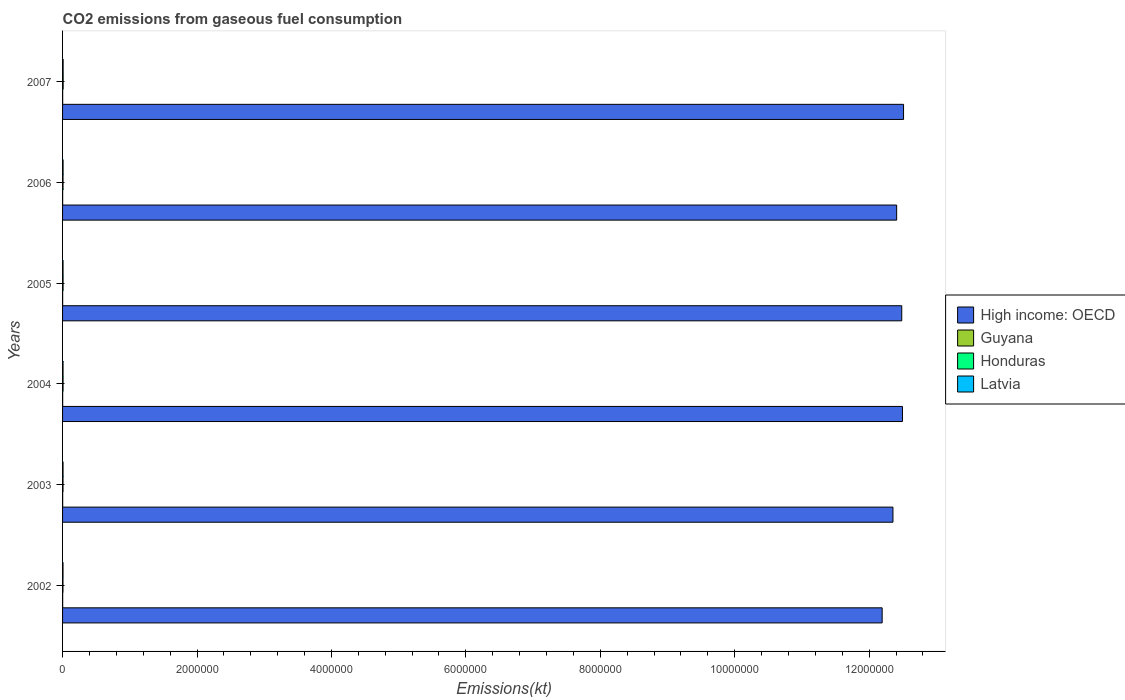Are the number of bars per tick equal to the number of legend labels?
Keep it short and to the point. Yes. Are the number of bars on each tick of the Y-axis equal?
Your response must be concise. Yes. How many bars are there on the 2nd tick from the bottom?
Your answer should be compact. 4. What is the label of the 5th group of bars from the top?
Offer a very short reply. 2003. What is the amount of CO2 emitted in High income: OECD in 2007?
Offer a very short reply. 1.25e+07. Across all years, what is the maximum amount of CO2 emitted in Honduras?
Give a very brief answer. 8778.8. Across all years, what is the minimum amount of CO2 emitted in High income: OECD?
Offer a very short reply. 1.22e+07. In which year was the amount of CO2 emitted in Latvia maximum?
Offer a very short reply. 2007. What is the total amount of CO2 emitted in High income: OECD in the graph?
Offer a terse response. 7.44e+07. What is the difference between the amount of CO2 emitted in Latvia in 2005 and that in 2007?
Your answer should be very brief. -1140.44. What is the difference between the amount of CO2 emitted in Latvia in 2006 and the amount of CO2 emitted in High income: OECD in 2005?
Provide a short and direct response. -1.25e+07. What is the average amount of CO2 emitted in Honduras per year?
Offer a terse response. 7261.27. In the year 2006, what is the difference between the amount of CO2 emitted in High income: OECD and amount of CO2 emitted in Guyana?
Your answer should be compact. 1.24e+07. What is the ratio of the amount of CO2 emitted in Latvia in 2003 to that in 2007?
Ensure brevity in your answer.  0.85. What is the difference between the highest and the second highest amount of CO2 emitted in Guyana?
Keep it short and to the point. 47.67. What is the difference between the highest and the lowest amount of CO2 emitted in Honduras?
Ensure brevity in your answer.  2687.91. Is the sum of the amount of CO2 emitted in Guyana in 2002 and 2003 greater than the maximum amount of CO2 emitted in Latvia across all years?
Keep it short and to the point. No. Is it the case that in every year, the sum of the amount of CO2 emitted in Guyana and amount of CO2 emitted in High income: OECD is greater than the sum of amount of CO2 emitted in Latvia and amount of CO2 emitted in Honduras?
Ensure brevity in your answer.  Yes. What does the 2nd bar from the top in 2004 represents?
Provide a succinct answer. Honduras. What does the 4th bar from the bottom in 2003 represents?
Give a very brief answer. Latvia. Is it the case that in every year, the sum of the amount of CO2 emitted in Guyana and amount of CO2 emitted in Honduras is greater than the amount of CO2 emitted in High income: OECD?
Your answer should be very brief. No. How many bars are there?
Provide a succinct answer. 24. How many years are there in the graph?
Offer a very short reply. 6. Does the graph contain grids?
Your answer should be compact. No. How many legend labels are there?
Offer a very short reply. 4. What is the title of the graph?
Keep it short and to the point. CO2 emissions from gaseous fuel consumption. Does "Libya" appear as one of the legend labels in the graph?
Make the answer very short. No. What is the label or title of the X-axis?
Your answer should be compact. Emissions(kt). What is the label or title of the Y-axis?
Give a very brief answer. Years. What is the Emissions(kt) of High income: OECD in 2002?
Offer a terse response. 1.22e+07. What is the Emissions(kt) of Guyana in 2002?
Provide a succinct answer. 1580.48. What is the Emissions(kt) of Honduras in 2002?
Give a very brief answer. 6090.89. What is the Emissions(kt) of Latvia in 2002?
Ensure brevity in your answer.  6651.94. What is the Emissions(kt) in High income: OECD in 2003?
Provide a short and direct response. 1.24e+07. What is the Emissions(kt) in Guyana in 2003?
Your response must be concise. 1565.81. What is the Emissions(kt) of Honduras in 2003?
Offer a very short reply. 6769.28. What is the Emissions(kt) of Latvia in 2003?
Ensure brevity in your answer.  7088.31. What is the Emissions(kt) in High income: OECD in 2004?
Offer a terse response. 1.25e+07. What is the Emissions(kt) of Guyana in 2004?
Your response must be concise. 1628.15. What is the Emissions(kt) of Honduras in 2004?
Your answer should be compact. 7367. What is the Emissions(kt) in Latvia in 2004?
Offer a very short reply. 7132.31. What is the Emissions(kt) in High income: OECD in 2005?
Provide a succinct answer. 1.25e+07. What is the Emissions(kt) in Guyana in 2005?
Offer a terse response. 1437.46. What is the Emissions(kt) in Honduras in 2005?
Give a very brief answer. 7554.02. What is the Emissions(kt) of Latvia in 2005?
Keep it short and to the point. 7176.32. What is the Emissions(kt) in High income: OECD in 2006?
Provide a succinct answer. 1.24e+07. What is the Emissions(kt) in Guyana in 2006?
Make the answer very short. 1290.78. What is the Emissions(kt) of Honduras in 2006?
Offer a very short reply. 7007.64. What is the Emissions(kt) of Latvia in 2006?
Provide a succinct answer. 7583.36. What is the Emissions(kt) of High income: OECD in 2007?
Provide a succinct answer. 1.25e+07. What is the Emissions(kt) in Guyana in 2007?
Ensure brevity in your answer.  1562.14. What is the Emissions(kt) in Honduras in 2007?
Offer a terse response. 8778.8. What is the Emissions(kt) of Latvia in 2007?
Give a very brief answer. 8316.76. Across all years, what is the maximum Emissions(kt) in High income: OECD?
Provide a succinct answer. 1.25e+07. Across all years, what is the maximum Emissions(kt) of Guyana?
Offer a very short reply. 1628.15. Across all years, what is the maximum Emissions(kt) of Honduras?
Keep it short and to the point. 8778.8. Across all years, what is the maximum Emissions(kt) in Latvia?
Ensure brevity in your answer.  8316.76. Across all years, what is the minimum Emissions(kt) in High income: OECD?
Your response must be concise. 1.22e+07. Across all years, what is the minimum Emissions(kt) of Guyana?
Ensure brevity in your answer.  1290.78. Across all years, what is the minimum Emissions(kt) of Honduras?
Your answer should be very brief. 6090.89. Across all years, what is the minimum Emissions(kt) in Latvia?
Keep it short and to the point. 6651.94. What is the total Emissions(kt) in High income: OECD in the graph?
Offer a very short reply. 7.44e+07. What is the total Emissions(kt) of Guyana in the graph?
Provide a succinct answer. 9064.82. What is the total Emissions(kt) of Honduras in the graph?
Offer a very short reply. 4.36e+04. What is the total Emissions(kt) in Latvia in the graph?
Give a very brief answer. 4.39e+04. What is the difference between the Emissions(kt) of High income: OECD in 2002 and that in 2003?
Your answer should be compact. -1.61e+05. What is the difference between the Emissions(kt) in Guyana in 2002 and that in 2003?
Provide a short and direct response. 14.67. What is the difference between the Emissions(kt) of Honduras in 2002 and that in 2003?
Offer a terse response. -678.39. What is the difference between the Emissions(kt) of Latvia in 2002 and that in 2003?
Offer a terse response. -436.37. What is the difference between the Emissions(kt) of High income: OECD in 2002 and that in 2004?
Keep it short and to the point. -3.02e+05. What is the difference between the Emissions(kt) in Guyana in 2002 and that in 2004?
Your response must be concise. -47.67. What is the difference between the Emissions(kt) in Honduras in 2002 and that in 2004?
Ensure brevity in your answer.  -1276.12. What is the difference between the Emissions(kt) of Latvia in 2002 and that in 2004?
Offer a terse response. -480.38. What is the difference between the Emissions(kt) of High income: OECD in 2002 and that in 2005?
Your answer should be compact. -2.91e+05. What is the difference between the Emissions(kt) of Guyana in 2002 and that in 2005?
Provide a short and direct response. 143.01. What is the difference between the Emissions(kt) of Honduras in 2002 and that in 2005?
Make the answer very short. -1463.13. What is the difference between the Emissions(kt) in Latvia in 2002 and that in 2005?
Your answer should be compact. -524.38. What is the difference between the Emissions(kt) of High income: OECD in 2002 and that in 2006?
Provide a short and direct response. -2.16e+05. What is the difference between the Emissions(kt) of Guyana in 2002 and that in 2006?
Provide a succinct answer. 289.69. What is the difference between the Emissions(kt) of Honduras in 2002 and that in 2006?
Offer a very short reply. -916.75. What is the difference between the Emissions(kt) of Latvia in 2002 and that in 2006?
Offer a very short reply. -931.42. What is the difference between the Emissions(kt) in High income: OECD in 2002 and that in 2007?
Provide a short and direct response. -3.18e+05. What is the difference between the Emissions(kt) of Guyana in 2002 and that in 2007?
Ensure brevity in your answer.  18.34. What is the difference between the Emissions(kt) of Honduras in 2002 and that in 2007?
Make the answer very short. -2687.91. What is the difference between the Emissions(kt) of Latvia in 2002 and that in 2007?
Offer a very short reply. -1664.82. What is the difference between the Emissions(kt) in High income: OECD in 2003 and that in 2004?
Keep it short and to the point. -1.41e+05. What is the difference between the Emissions(kt) in Guyana in 2003 and that in 2004?
Keep it short and to the point. -62.34. What is the difference between the Emissions(kt) in Honduras in 2003 and that in 2004?
Keep it short and to the point. -597.72. What is the difference between the Emissions(kt) of Latvia in 2003 and that in 2004?
Offer a very short reply. -44. What is the difference between the Emissions(kt) in High income: OECD in 2003 and that in 2005?
Make the answer very short. -1.31e+05. What is the difference between the Emissions(kt) in Guyana in 2003 and that in 2005?
Provide a short and direct response. 128.34. What is the difference between the Emissions(kt) in Honduras in 2003 and that in 2005?
Make the answer very short. -784.74. What is the difference between the Emissions(kt) of Latvia in 2003 and that in 2005?
Ensure brevity in your answer.  -88.01. What is the difference between the Emissions(kt) in High income: OECD in 2003 and that in 2006?
Ensure brevity in your answer.  -5.51e+04. What is the difference between the Emissions(kt) in Guyana in 2003 and that in 2006?
Offer a terse response. 275.02. What is the difference between the Emissions(kt) of Honduras in 2003 and that in 2006?
Provide a short and direct response. -238.35. What is the difference between the Emissions(kt) in Latvia in 2003 and that in 2006?
Your response must be concise. -495.05. What is the difference between the Emissions(kt) in High income: OECD in 2003 and that in 2007?
Keep it short and to the point. -1.58e+05. What is the difference between the Emissions(kt) of Guyana in 2003 and that in 2007?
Offer a terse response. 3.67. What is the difference between the Emissions(kt) of Honduras in 2003 and that in 2007?
Keep it short and to the point. -2009.52. What is the difference between the Emissions(kt) of Latvia in 2003 and that in 2007?
Offer a very short reply. -1228.44. What is the difference between the Emissions(kt) of High income: OECD in 2004 and that in 2005?
Keep it short and to the point. 1.07e+04. What is the difference between the Emissions(kt) of Guyana in 2004 and that in 2005?
Your answer should be compact. 190.68. What is the difference between the Emissions(kt) in Honduras in 2004 and that in 2005?
Your answer should be compact. -187.02. What is the difference between the Emissions(kt) in Latvia in 2004 and that in 2005?
Your answer should be compact. -44. What is the difference between the Emissions(kt) of High income: OECD in 2004 and that in 2006?
Give a very brief answer. 8.64e+04. What is the difference between the Emissions(kt) in Guyana in 2004 and that in 2006?
Provide a short and direct response. 337.36. What is the difference between the Emissions(kt) of Honduras in 2004 and that in 2006?
Offer a terse response. 359.37. What is the difference between the Emissions(kt) in Latvia in 2004 and that in 2006?
Offer a terse response. -451.04. What is the difference between the Emissions(kt) in High income: OECD in 2004 and that in 2007?
Your answer should be very brief. -1.61e+04. What is the difference between the Emissions(kt) in Guyana in 2004 and that in 2007?
Provide a short and direct response. 66.01. What is the difference between the Emissions(kt) of Honduras in 2004 and that in 2007?
Keep it short and to the point. -1411.8. What is the difference between the Emissions(kt) of Latvia in 2004 and that in 2007?
Offer a terse response. -1184.44. What is the difference between the Emissions(kt) of High income: OECD in 2005 and that in 2006?
Ensure brevity in your answer.  7.57e+04. What is the difference between the Emissions(kt) of Guyana in 2005 and that in 2006?
Offer a very short reply. 146.68. What is the difference between the Emissions(kt) of Honduras in 2005 and that in 2006?
Ensure brevity in your answer.  546.38. What is the difference between the Emissions(kt) of Latvia in 2005 and that in 2006?
Your answer should be compact. -407.04. What is the difference between the Emissions(kt) in High income: OECD in 2005 and that in 2007?
Ensure brevity in your answer.  -2.69e+04. What is the difference between the Emissions(kt) of Guyana in 2005 and that in 2007?
Offer a terse response. -124.68. What is the difference between the Emissions(kt) in Honduras in 2005 and that in 2007?
Your response must be concise. -1224.78. What is the difference between the Emissions(kt) in Latvia in 2005 and that in 2007?
Your answer should be very brief. -1140.44. What is the difference between the Emissions(kt) of High income: OECD in 2006 and that in 2007?
Provide a succinct answer. -1.03e+05. What is the difference between the Emissions(kt) of Guyana in 2006 and that in 2007?
Your answer should be very brief. -271.36. What is the difference between the Emissions(kt) in Honduras in 2006 and that in 2007?
Make the answer very short. -1771.16. What is the difference between the Emissions(kt) of Latvia in 2006 and that in 2007?
Ensure brevity in your answer.  -733.4. What is the difference between the Emissions(kt) in High income: OECD in 2002 and the Emissions(kt) in Guyana in 2003?
Your response must be concise. 1.22e+07. What is the difference between the Emissions(kt) of High income: OECD in 2002 and the Emissions(kt) of Honduras in 2003?
Ensure brevity in your answer.  1.22e+07. What is the difference between the Emissions(kt) of High income: OECD in 2002 and the Emissions(kt) of Latvia in 2003?
Provide a succinct answer. 1.22e+07. What is the difference between the Emissions(kt) of Guyana in 2002 and the Emissions(kt) of Honduras in 2003?
Your answer should be compact. -5188.81. What is the difference between the Emissions(kt) in Guyana in 2002 and the Emissions(kt) in Latvia in 2003?
Offer a terse response. -5507.83. What is the difference between the Emissions(kt) of Honduras in 2002 and the Emissions(kt) of Latvia in 2003?
Provide a short and direct response. -997.42. What is the difference between the Emissions(kt) of High income: OECD in 2002 and the Emissions(kt) of Guyana in 2004?
Your answer should be compact. 1.22e+07. What is the difference between the Emissions(kt) of High income: OECD in 2002 and the Emissions(kt) of Honduras in 2004?
Provide a short and direct response. 1.22e+07. What is the difference between the Emissions(kt) of High income: OECD in 2002 and the Emissions(kt) of Latvia in 2004?
Make the answer very short. 1.22e+07. What is the difference between the Emissions(kt) of Guyana in 2002 and the Emissions(kt) of Honduras in 2004?
Your answer should be compact. -5786.53. What is the difference between the Emissions(kt) of Guyana in 2002 and the Emissions(kt) of Latvia in 2004?
Your answer should be very brief. -5551.84. What is the difference between the Emissions(kt) of Honduras in 2002 and the Emissions(kt) of Latvia in 2004?
Give a very brief answer. -1041.43. What is the difference between the Emissions(kt) in High income: OECD in 2002 and the Emissions(kt) in Guyana in 2005?
Provide a short and direct response. 1.22e+07. What is the difference between the Emissions(kt) in High income: OECD in 2002 and the Emissions(kt) in Honduras in 2005?
Provide a short and direct response. 1.22e+07. What is the difference between the Emissions(kt) in High income: OECD in 2002 and the Emissions(kt) in Latvia in 2005?
Give a very brief answer. 1.22e+07. What is the difference between the Emissions(kt) of Guyana in 2002 and the Emissions(kt) of Honduras in 2005?
Your response must be concise. -5973.54. What is the difference between the Emissions(kt) of Guyana in 2002 and the Emissions(kt) of Latvia in 2005?
Your answer should be very brief. -5595.84. What is the difference between the Emissions(kt) of Honduras in 2002 and the Emissions(kt) of Latvia in 2005?
Your answer should be very brief. -1085.43. What is the difference between the Emissions(kt) of High income: OECD in 2002 and the Emissions(kt) of Guyana in 2006?
Your response must be concise. 1.22e+07. What is the difference between the Emissions(kt) of High income: OECD in 2002 and the Emissions(kt) of Honduras in 2006?
Ensure brevity in your answer.  1.22e+07. What is the difference between the Emissions(kt) in High income: OECD in 2002 and the Emissions(kt) in Latvia in 2006?
Your answer should be compact. 1.22e+07. What is the difference between the Emissions(kt) of Guyana in 2002 and the Emissions(kt) of Honduras in 2006?
Ensure brevity in your answer.  -5427.16. What is the difference between the Emissions(kt) of Guyana in 2002 and the Emissions(kt) of Latvia in 2006?
Give a very brief answer. -6002.88. What is the difference between the Emissions(kt) of Honduras in 2002 and the Emissions(kt) of Latvia in 2006?
Make the answer very short. -1492.47. What is the difference between the Emissions(kt) in High income: OECD in 2002 and the Emissions(kt) in Guyana in 2007?
Provide a short and direct response. 1.22e+07. What is the difference between the Emissions(kt) in High income: OECD in 2002 and the Emissions(kt) in Honduras in 2007?
Your response must be concise. 1.22e+07. What is the difference between the Emissions(kt) of High income: OECD in 2002 and the Emissions(kt) of Latvia in 2007?
Provide a succinct answer. 1.22e+07. What is the difference between the Emissions(kt) in Guyana in 2002 and the Emissions(kt) in Honduras in 2007?
Give a very brief answer. -7198.32. What is the difference between the Emissions(kt) in Guyana in 2002 and the Emissions(kt) in Latvia in 2007?
Ensure brevity in your answer.  -6736.28. What is the difference between the Emissions(kt) in Honduras in 2002 and the Emissions(kt) in Latvia in 2007?
Provide a short and direct response. -2225.87. What is the difference between the Emissions(kt) of High income: OECD in 2003 and the Emissions(kt) of Guyana in 2004?
Give a very brief answer. 1.24e+07. What is the difference between the Emissions(kt) of High income: OECD in 2003 and the Emissions(kt) of Honduras in 2004?
Your response must be concise. 1.23e+07. What is the difference between the Emissions(kt) in High income: OECD in 2003 and the Emissions(kt) in Latvia in 2004?
Keep it short and to the point. 1.23e+07. What is the difference between the Emissions(kt) in Guyana in 2003 and the Emissions(kt) in Honduras in 2004?
Provide a succinct answer. -5801.19. What is the difference between the Emissions(kt) of Guyana in 2003 and the Emissions(kt) of Latvia in 2004?
Provide a succinct answer. -5566.51. What is the difference between the Emissions(kt) in Honduras in 2003 and the Emissions(kt) in Latvia in 2004?
Provide a succinct answer. -363.03. What is the difference between the Emissions(kt) in High income: OECD in 2003 and the Emissions(kt) in Guyana in 2005?
Offer a very short reply. 1.24e+07. What is the difference between the Emissions(kt) in High income: OECD in 2003 and the Emissions(kt) in Honduras in 2005?
Your answer should be compact. 1.23e+07. What is the difference between the Emissions(kt) of High income: OECD in 2003 and the Emissions(kt) of Latvia in 2005?
Offer a very short reply. 1.23e+07. What is the difference between the Emissions(kt) in Guyana in 2003 and the Emissions(kt) in Honduras in 2005?
Provide a short and direct response. -5988.21. What is the difference between the Emissions(kt) in Guyana in 2003 and the Emissions(kt) in Latvia in 2005?
Keep it short and to the point. -5610.51. What is the difference between the Emissions(kt) in Honduras in 2003 and the Emissions(kt) in Latvia in 2005?
Ensure brevity in your answer.  -407.04. What is the difference between the Emissions(kt) in High income: OECD in 2003 and the Emissions(kt) in Guyana in 2006?
Give a very brief answer. 1.24e+07. What is the difference between the Emissions(kt) of High income: OECD in 2003 and the Emissions(kt) of Honduras in 2006?
Provide a succinct answer. 1.23e+07. What is the difference between the Emissions(kt) of High income: OECD in 2003 and the Emissions(kt) of Latvia in 2006?
Offer a terse response. 1.23e+07. What is the difference between the Emissions(kt) of Guyana in 2003 and the Emissions(kt) of Honduras in 2006?
Your answer should be compact. -5441.83. What is the difference between the Emissions(kt) of Guyana in 2003 and the Emissions(kt) of Latvia in 2006?
Keep it short and to the point. -6017.55. What is the difference between the Emissions(kt) of Honduras in 2003 and the Emissions(kt) of Latvia in 2006?
Provide a succinct answer. -814.07. What is the difference between the Emissions(kt) in High income: OECD in 2003 and the Emissions(kt) in Guyana in 2007?
Give a very brief answer. 1.24e+07. What is the difference between the Emissions(kt) of High income: OECD in 2003 and the Emissions(kt) of Honduras in 2007?
Keep it short and to the point. 1.23e+07. What is the difference between the Emissions(kt) in High income: OECD in 2003 and the Emissions(kt) in Latvia in 2007?
Provide a short and direct response. 1.23e+07. What is the difference between the Emissions(kt) in Guyana in 2003 and the Emissions(kt) in Honduras in 2007?
Make the answer very short. -7212.99. What is the difference between the Emissions(kt) in Guyana in 2003 and the Emissions(kt) in Latvia in 2007?
Keep it short and to the point. -6750.95. What is the difference between the Emissions(kt) of Honduras in 2003 and the Emissions(kt) of Latvia in 2007?
Ensure brevity in your answer.  -1547.47. What is the difference between the Emissions(kt) in High income: OECD in 2004 and the Emissions(kt) in Guyana in 2005?
Provide a succinct answer. 1.25e+07. What is the difference between the Emissions(kt) in High income: OECD in 2004 and the Emissions(kt) in Honduras in 2005?
Provide a short and direct response. 1.25e+07. What is the difference between the Emissions(kt) in High income: OECD in 2004 and the Emissions(kt) in Latvia in 2005?
Your answer should be very brief. 1.25e+07. What is the difference between the Emissions(kt) of Guyana in 2004 and the Emissions(kt) of Honduras in 2005?
Provide a short and direct response. -5925.87. What is the difference between the Emissions(kt) of Guyana in 2004 and the Emissions(kt) of Latvia in 2005?
Ensure brevity in your answer.  -5548.17. What is the difference between the Emissions(kt) in Honduras in 2004 and the Emissions(kt) in Latvia in 2005?
Provide a short and direct response. 190.68. What is the difference between the Emissions(kt) of High income: OECD in 2004 and the Emissions(kt) of Guyana in 2006?
Give a very brief answer. 1.25e+07. What is the difference between the Emissions(kt) in High income: OECD in 2004 and the Emissions(kt) in Honduras in 2006?
Offer a very short reply. 1.25e+07. What is the difference between the Emissions(kt) in High income: OECD in 2004 and the Emissions(kt) in Latvia in 2006?
Provide a short and direct response. 1.25e+07. What is the difference between the Emissions(kt) in Guyana in 2004 and the Emissions(kt) in Honduras in 2006?
Make the answer very short. -5379.49. What is the difference between the Emissions(kt) of Guyana in 2004 and the Emissions(kt) of Latvia in 2006?
Your answer should be compact. -5955.21. What is the difference between the Emissions(kt) in Honduras in 2004 and the Emissions(kt) in Latvia in 2006?
Offer a terse response. -216.35. What is the difference between the Emissions(kt) in High income: OECD in 2004 and the Emissions(kt) in Guyana in 2007?
Give a very brief answer. 1.25e+07. What is the difference between the Emissions(kt) of High income: OECD in 2004 and the Emissions(kt) of Honduras in 2007?
Your answer should be compact. 1.25e+07. What is the difference between the Emissions(kt) in High income: OECD in 2004 and the Emissions(kt) in Latvia in 2007?
Provide a succinct answer. 1.25e+07. What is the difference between the Emissions(kt) in Guyana in 2004 and the Emissions(kt) in Honduras in 2007?
Offer a very short reply. -7150.65. What is the difference between the Emissions(kt) of Guyana in 2004 and the Emissions(kt) of Latvia in 2007?
Your answer should be compact. -6688.61. What is the difference between the Emissions(kt) in Honduras in 2004 and the Emissions(kt) in Latvia in 2007?
Keep it short and to the point. -949.75. What is the difference between the Emissions(kt) of High income: OECD in 2005 and the Emissions(kt) of Guyana in 2006?
Make the answer very short. 1.25e+07. What is the difference between the Emissions(kt) in High income: OECD in 2005 and the Emissions(kt) in Honduras in 2006?
Your answer should be compact. 1.25e+07. What is the difference between the Emissions(kt) of High income: OECD in 2005 and the Emissions(kt) of Latvia in 2006?
Offer a terse response. 1.25e+07. What is the difference between the Emissions(kt) in Guyana in 2005 and the Emissions(kt) in Honduras in 2006?
Give a very brief answer. -5570.17. What is the difference between the Emissions(kt) in Guyana in 2005 and the Emissions(kt) in Latvia in 2006?
Provide a succinct answer. -6145.89. What is the difference between the Emissions(kt) in Honduras in 2005 and the Emissions(kt) in Latvia in 2006?
Your response must be concise. -29.34. What is the difference between the Emissions(kt) in High income: OECD in 2005 and the Emissions(kt) in Guyana in 2007?
Provide a short and direct response. 1.25e+07. What is the difference between the Emissions(kt) of High income: OECD in 2005 and the Emissions(kt) of Honduras in 2007?
Your answer should be very brief. 1.25e+07. What is the difference between the Emissions(kt) of High income: OECD in 2005 and the Emissions(kt) of Latvia in 2007?
Offer a terse response. 1.25e+07. What is the difference between the Emissions(kt) of Guyana in 2005 and the Emissions(kt) of Honduras in 2007?
Give a very brief answer. -7341.33. What is the difference between the Emissions(kt) of Guyana in 2005 and the Emissions(kt) of Latvia in 2007?
Keep it short and to the point. -6879.29. What is the difference between the Emissions(kt) in Honduras in 2005 and the Emissions(kt) in Latvia in 2007?
Ensure brevity in your answer.  -762.74. What is the difference between the Emissions(kt) in High income: OECD in 2006 and the Emissions(kt) in Guyana in 2007?
Offer a very short reply. 1.24e+07. What is the difference between the Emissions(kt) of High income: OECD in 2006 and the Emissions(kt) of Honduras in 2007?
Offer a terse response. 1.24e+07. What is the difference between the Emissions(kt) in High income: OECD in 2006 and the Emissions(kt) in Latvia in 2007?
Offer a very short reply. 1.24e+07. What is the difference between the Emissions(kt) in Guyana in 2006 and the Emissions(kt) in Honduras in 2007?
Provide a succinct answer. -7488.01. What is the difference between the Emissions(kt) of Guyana in 2006 and the Emissions(kt) of Latvia in 2007?
Give a very brief answer. -7025.97. What is the difference between the Emissions(kt) of Honduras in 2006 and the Emissions(kt) of Latvia in 2007?
Provide a succinct answer. -1309.12. What is the average Emissions(kt) of High income: OECD per year?
Your response must be concise. 1.24e+07. What is the average Emissions(kt) of Guyana per year?
Your answer should be very brief. 1510.8. What is the average Emissions(kt) of Honduras per year?
Offer a terse response. 7261.27. What is the average Emissions(kt) in Latvia per year?
Offer a terse response. 7324.83. In the year 2002, what is the difference between the Emissions(kt) of High income: OECD and Emissions(kt) of Guyana?
Ensure brevity in your answer.  1.22e+07. In the year 2002, what is the difference between the Emissions(kt) in High income: OECD and Emissions(kt) in Honduras?
Provide a short and direct response. 1.22e+07. In the year 2002, what is the difference between the Emissions(kt) in High income: OECD and Emissions(kt) in Latvia?
Your answer should be compact. 1.22e+07. In the year 2002, what is the difference between the Emissions(kt) in Guyana and Emissions(kt) in Honduras?
Provide a succinct answer. -4510.41. In the year 2002, what is the difference between the Emissions(kt) in Guyana and Emissions(kt) in Latvia?
Provide a succinct answer. -5071.46. In the year 2002, what is the difference between the Emissions(kt) of Honduras and Emissions(kt) of Latvia?
Provide a short and direct response. -561.05. In the year 2003, what is the difference between the Emissions(kt) in High income: OECD and Emissions(kt) in Guyana?
Ensure brevity in your answer.  1.24e+07. In the year 2003, what is the difference between the Emissions(kt) of High income: OECD and Emissions(kt) of Honduras?
Your answer should be very brief. 1.23e+07. In the year 2003, what is the difference between the Emissions(kt) of High income: OECD and Emissions(kt) of Latvia?
Your answer should be compact. 1.23e+07. In the year 2003, what is the difference between the Emissions(kt) of Guyana and Emissions(kt) of Honduras?
Provide a succinct answer. -5203.47. In the year 2003, what is the difference between the Emissions(kt) of Guyana and Emissions(kt) of Latvia?
Give a very brief answer. -5522.5. In the year 2003, what is the difference between the Emissions(kt) of Honduras and Emissions(kt) of Latvia?
Give a very brief answer. -319.03. In the year 2004, what is the difference between the Emissions(kt) of High income: OECD and Emissions(kt) of Guyana?
Offer a very short reply. 1.25e+07. In the year 2004, what is the difference between the Emissions(kt) of High income: OECD and Emissions(kt) of Honduras?
Offer a terse response. 1.25e+07. In the year 2004, what is the difference between the Emissions(kt) in High income: OECD and Emissions(kt) in Latvia?
Give a very brief answer. 1.25e+07. In the year 2004, what is the difference between the Emissions(kt) in Guyana and Emissions(kt) in Honduras?
Offer a terse response. -5738.85. In the year 2004, what is the difference between the Emissions(kt) in Guyana and Emissions(kt) in Latvia?
Provide a succinct answer. -5504.17. In the year 2004, what is the difference between the Emissions(kt) of Honduras and Emissions(kt) of Latvia?
Offer a terse response. 234.69. In the year 2005, what is the difference between the Emissions(kt) of High income: OECD and Emissions(kt) of Guyana?
Give a very brief answer. 1.25e+07. In the year 2005, what is the difference between the Emissions(kt) of High income: OECD and Emissions(kt) of Honduras?
Provide a short and direct response. 1.25e+07. In the year 2005, what is the difference between the Emissions(kt) of High income: OECD and Emissions(kt) of Latvia?
Ensure brevity in your answer.  1.25e+07. In the year 2005, what is the difference between the Emissions(kt) of Guyana and Emissions(kt) of Honduras?
Your response must be concise. -6116.56. In the year 2005, what is the difference between the Emissions(kt) in Guyana and Emissions(kt) in Latvia?
Ensure brevity in your answer.  -5738.85. In the year 2005, what is the difference between the Emissions(kt) of Honduras and Emissions(kt) of Latvia?
Offer a very short reply. 377.7. In the year 2006, what is the difference between the Emissions(kt) of High income: OECD and Emissions(kt) of Guyana?
Ensure brevity in your answer.  1.24e+07. In the year 2006, what is the difference between the Emissions(kt) of High income: OECD and Emissions(kt) of Honduras?
Your response must be concise. 1.24e+07. In the year 2006, what is the difference between the Emissions(kt) of High income: OECD and Emissions(kt) of Latvia?
Ensure brevity in your answer.  1.24e+07. In the year 2006, what is the difference between the Emissions(kt) of Guyana and Emissions(kt) of Honduras?
Keep it short and to the point. -5716.85. In the year 2006, what is the difference between the Emissions(kt) of Guyana and Emissions(kt) of Latvia?
Your answer should be very brief. -6292.57. In the year 2006, what is the difference between the Emissions(kt) in Honduras and Emissions(kt) in Latvia?
Your answer should be very brief. -575.72. In the year 2007, what is the difference between the Emissions(kt) of High income: OECD and Emissions(kt) of Guyana?
Provide a succinct answer. 1.25e+07. In the year 2007, what is the difference between the Emissions(kt) of High income: OECD and Emissions(kt) of Honduras?
Your answer should be compact. 1.25e+07. In the year 2007, what is the difference between the Emissions(kt) in High income: OECD and Emissions(kt) in Latvia?
Provide a succinct answer. 1.25e+07. In the year 2007, what is the difference between the Emissions(kt) of Guyana and Emissions(kt) of Honduras?
Provide a succinct answer. -7216.66. In the year 2007, what is the difference between the Emissions(kt) in Guyana and Emissions(kt) in Latvia?
Make the answer very short. -6754.61. In the year 2007, what is the difference between the Emissions(kt) of Honduras and Emissions(kt) of Latvia?
Give a very brief answer. 462.04. What is the ratio of the Emissions(kt) in High income: OECD in 2002 to that in 2003?
Offer a terse response. 0.99. What is the ratio of the Emissions(kt) of Guyana in 2002 to that in 2003?
Provide a succinct answer. 1.01. What is the ratio of the Emissions(kt) of Honduras in 2002 to that in 2003?
Give a very brief answer. 0.9. What is the ratio of the Emissions(kt) of Latvia in 2002 to that in 2003?
Offer a terse response. 0.94. What is the ratio of the Emissions(kt) of High income: OECD in 2002 to that in 2004?
Make the answer very short. 0.98. What is the ratio of the Emissions(kt) of Guyana in 2002 to that in 2004?
Offer a very short reply. 0.97. What is the ratio of the Emissions(kt) of Honduras in 2002 to that in 2004?
Provide a short and direct response. 0.83. What is the ratio of the Emissions(kt) of Latvia in 2002 to that in 2004?
Your answer should be compact. 0.93. What is the ratio of the Emissions(kt) in High income: OECD in 2002 to that in 2005?
Give a very brief answer. 0.98. What is the ratio of the Emissions(kt) in Guyana in 2002 to that in 2005?
Your answer should be very brief. 1.1. What is the ratio of the Emissions(kt) in Honduras in 2002 to that in 2005?
Offer a very short reply. 0.81. What is the ratio of the Emissions(kt) in Latvia in 2002 to that in 2005?
Provide a short and direct response. 0.93. What is the ratio of the Emissions(kt) of High income: OECD in 2002 to that in 2006?
Ensure brevity in your answer.  0.98. What is the ratio of the Emissions(kt) in Guyana in 2002 to that in 2006?
Give a very brief answer. 1.22. What is the ratio of the Emissions(kt) of Honduras in 2002 to that in 2006?
Ensure brevity in your answer.  0.87. What is the ratio of the Emissions(kt) of Latvia in 2002 to that in 2006?
Offer a terse response. 0.88. What is the ratio of the Emissions(kt) of High income: OECD in 2002 to that in 2007?
Offer a terse response. 0.97. What is the ratio of the Emissions(kt) in Guyana in 2002 to that in 2007?
Your answer should be very brief. 1.01. What is the ratio of the Emissions(kt) in Honduras in 2002 to that in 2007?
Your response must be concise. 0.69. What is the ratio of the Emissions(kt) in Latvia in 2002 to that in 2007?
Give a very brief answer. 0.8. What is the ratio of the Emissions(kt) of High income: OECD in 2003 to that in 2004?
Your answer should be compact. 0.99. What is the ratio of the Emissions(kt) in Guyana in 2003 to that in 2004?
Make the answer very short. 0.96. What is the ratio of the Emissions(kt) of Honduras in 2003 to that in 2004?
Provide a succinct answer. 0.92. What is the ratio of the Emissions(kt) of Latvia in 2003 to that in 2004?
Your answer should be very brief. 0.99. What is the ratio of the Emissions(kt) in Guyana in 2003 to that in 2005?
Provide a succinct answer. 1.09. What is the ratio of the Emissions(kt) of Honduras in 2003 to that in 2005?
Give a very brief answer. 0.9. What is the ratio of the Emissions(kt) in Latvia in 2003 to that in 2005?
Ensure brevity in your answer.  0.99. What is the ratio of the Emissions(kt) of High income: OECD in 2003 to that in 2006?
Ensure brevity in your answer.  1. What is the ratio of the Emissions(kt) of Guyana in 2003 to that in 2006?
Ensure brevity in your answer.  1.21. What is the ratio of the Emissions(kt) in Latvia in 2003 to that in 2006?
Offer a very short reply. 0.93. What is the ratio of the Emissions(kt) in High income: OECD in 2003 to that in 2007?
Your response must be concise. 0.99. What is the ratio of the Emissions(kt) of Guyana in 2003 to that in 2007?
Offer a very short reply. 1. What is the ratio of the Emissions(kt) of Honduras in 2003 to that in 2007?
Ensure brevity in your answer.  0.77. What is the ratio of the Emissions(kt) of Latvia in 2003 to that in 2007?
Give a very brief answer. 0.85. What is the ratio of the Emissions(kt) of Guyana in 2004 to that in 2005?
Give a very brief answer. 1.13. What is the ratio of the Emissions(kt) of Honduras in 2004 to that in 2005?
Provide a short and direct response. 0.98. What is the ratio of the Emissions(kt) of Guyana in 2004 to that in 2006?
Give a very brief answer. 1.26. What is the ratio of the Emissions(kt) in Honduras in 2004 to that in 2006?
Ensure brevity in your answer.  1.05. What is the ratio of the Emissions(kt) of Latvia in 2004 to that in 2006?
Offer a very short reply. 0.94. What is the ratio of the Emissions(kt) in Guyana in 2004 to that in 2007?
Ensure brevity in your answer.  1.04. What is the ratio of the Emissions(kt) in Honduras in 2004 to that in 2007?
Provide a short and direct response. 0.84. What is the ratio of the Emissions(kt) in Latvia in 2004 to that in 2007?
Provide a short and direct response. 0.86. What is the ratio of the Emissions(kt) in High income: OECD in 2005 to that in 2006?
Provide a succinct answer. 1.01. What is the ratio of the Emissions(kt) of Guyana in 2005 to that in 2006?
Provide a short and direct response. 1.11. What is the ratio of the Emissions(kt) in Honduras in 2005 to that in 2006?
Ensure brevity in your answer.  1.08. What is the ratio of the Emissions(kt) of Latvia in 2005 to that in 2006?
Your answer should be very brief. 0.95. What is the ratio of the Emissions(kt) of Guyana in 2005 to that in 2007?
Your answer should be very brief. 0.92. What is the ratio of the Emissions(kt) of Honduras in 2005 to that in 2007?
Your answer should be compact. 0.86. What is the ratio of the Emissions(kt) of Latvia in 2005 to that in 2007?
Keep it short and to the point. 0.86. What is the ratio of the Emissions(kt) in Guyana in 2006 to that in 2007?
Offer a terse response. 0.83. What is the ratio of the Emissions(kt) in Honduras in 2006 to that in 2007?
Give a very brief answer. 0.8. What is the ratio of the Emissions(kt) in Latvia in 2006 to that in 2007?
Provide a short and direct response. 0.91. What is the difference between the highest and the second highest Emissions(kt) of High income: OECD?
Ensure brevity in your answer.  1.61e+04. What is the difference between the highest and the second highest Emissions(kt) of Guyana?
Provide a short and direct response. 47.67. What is the difference between the highest and the second highest Emissions(kt) in Honduras?
Provide a succinct answer. 1224.78. What is the difference between the highest and the second highest Emissions(kt) in Latvia?
Your answer should be very brief. 733.4. What is the difference between the highest and the lowest Emissions(kt) of High income: OECD?
Provide a short and direct response. 3.18e+05. What is the difference between the highest and the lowest Emissions(kt) of Guyana?
Your response must be concise. 337.36. What is the difference between the highest and the lowest Emissions(kt) of Honduras?
Your response must be concise. 2687.91. What is the difference between the highest and the lowest Emissions(kt) in Latvia?
Provide a succinct answer. 1664.82. 